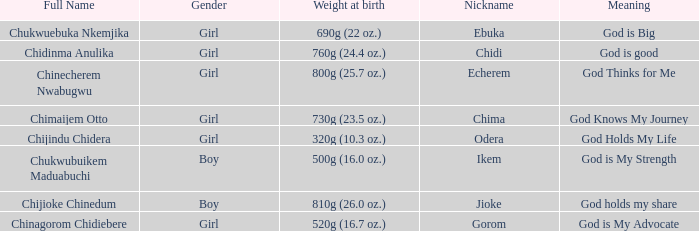How much did the girl, nicknamed Chidi, weigh at birth? 760g (24.4 oz.). 